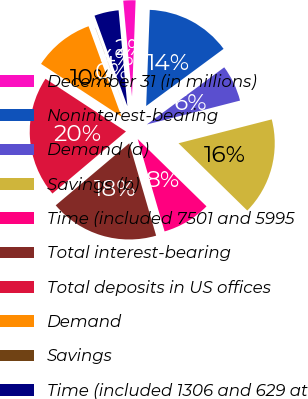Convert chart to OTSL. <chart><loc_0><loc_0><loc_500><loc_500><pie_chart><fcel>December 31 (in millions)<fcel>Noninterest-bearing<fcel>Demand (a)<fcel>Savings (b)<fcel>Time (included 7501 and 5995<fcel>Total interest-bearing<fcel>Total deposits in US offices<fcel>Demand<fcel>Savings<fcel>Time (included 1306 and 629 at<nl><fcel>2.05%<fcel>14.28%<fcel>6.13%<fcel>16.32%<fcel>8.17%<fcel>18.35%<fcel>20.39%<fcel>10.2%<fcel>0.02%<fcel>4.09%<nl></chart> 